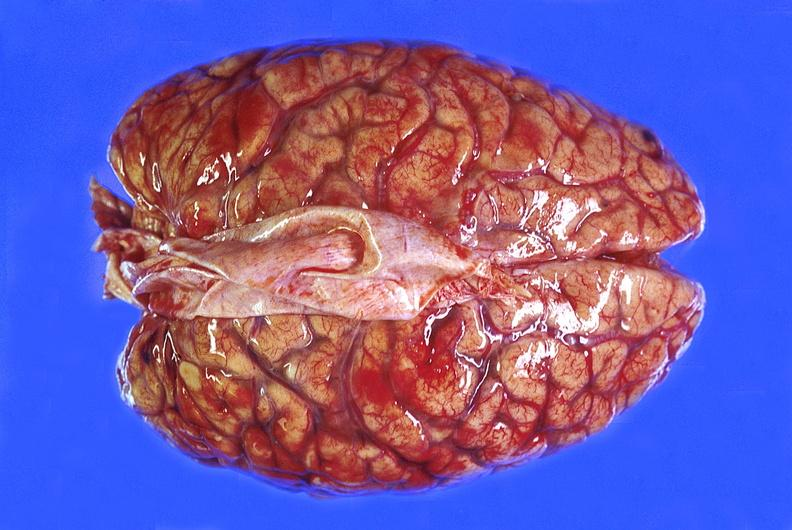what is present?
Answer the question using a single word or phrase. Nervous 